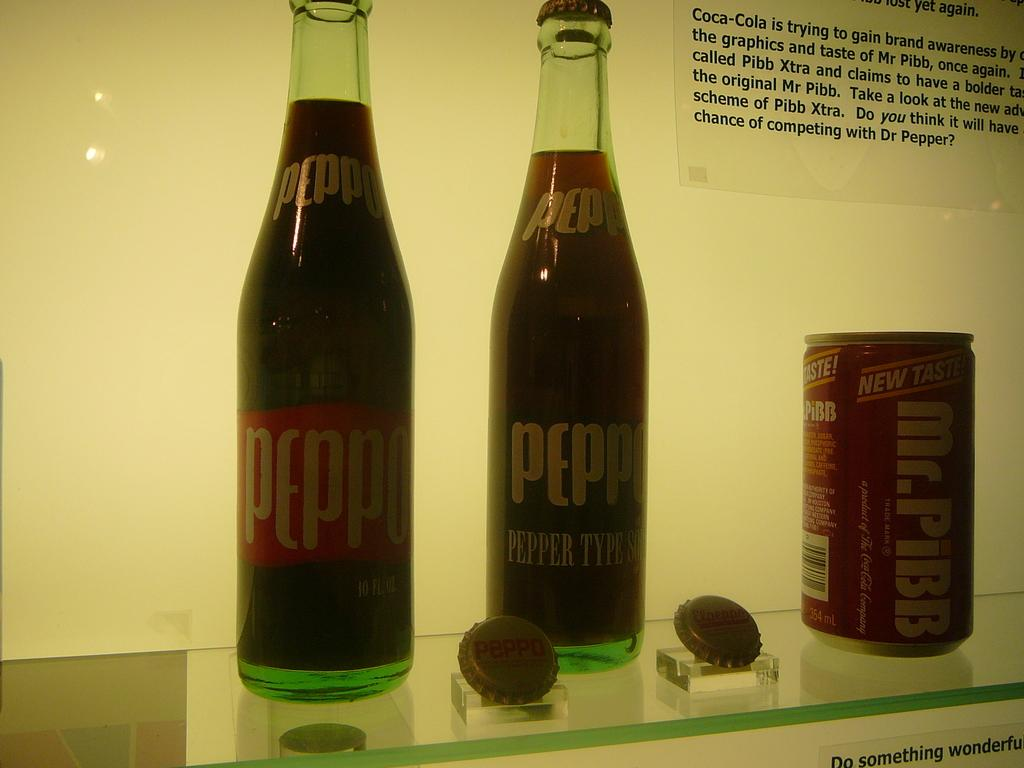<image>
Create a compact narrative representing the image presented. Two Peppo soda bottles next to a Mr. Pibb can 